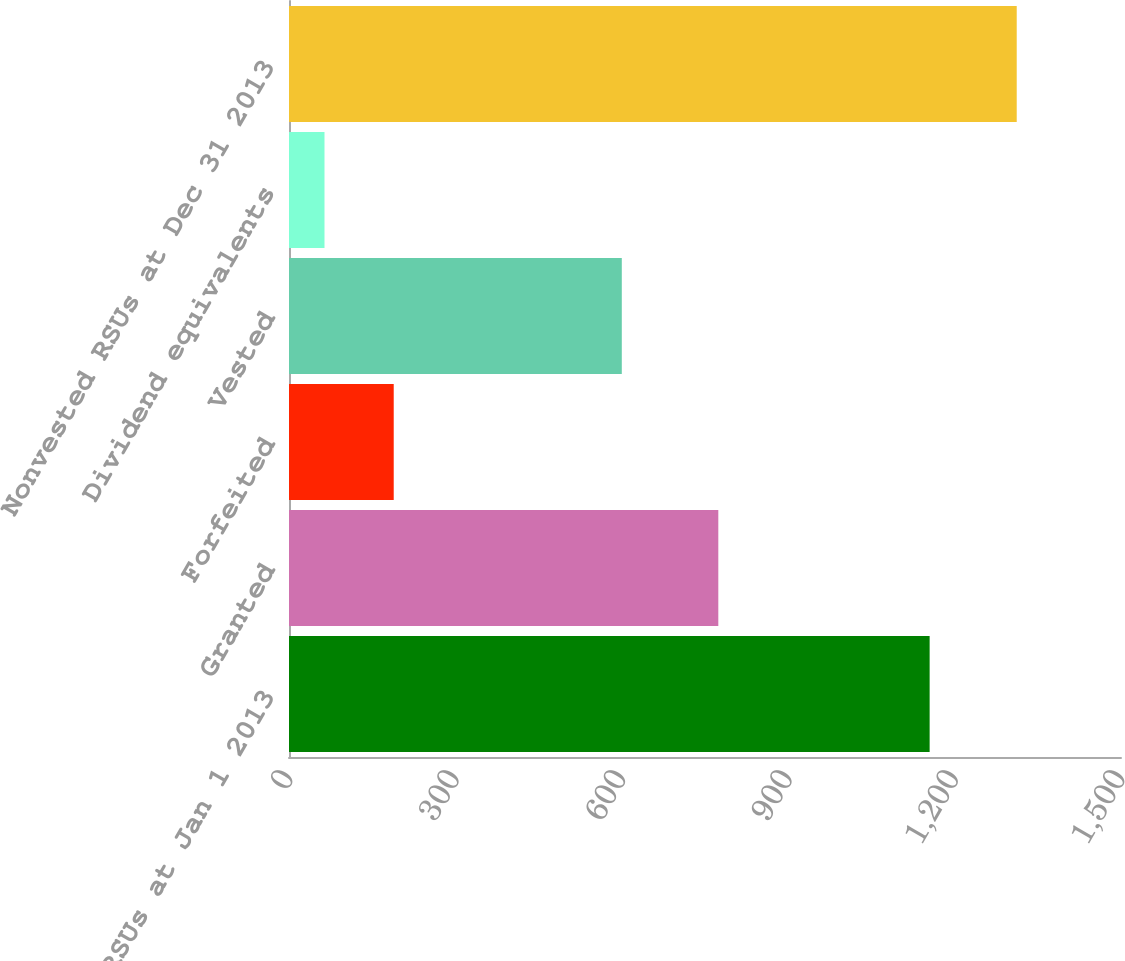<chart> <loc_0><loc_0><loc_500><loc_500><bar_chart><fcel>Nonvested RSUs at Jan 1 2013<fcel>Granted<fcel>Forfeited<fcel>Vested<fcel>Dividend equivalents<fcel>Nonvested RSUs at Dec 31 2013<nl><fcel>1155<fcel>774<fcel>188.8<fcel>600<fcel>64<fcel>1312<nl></chart> 